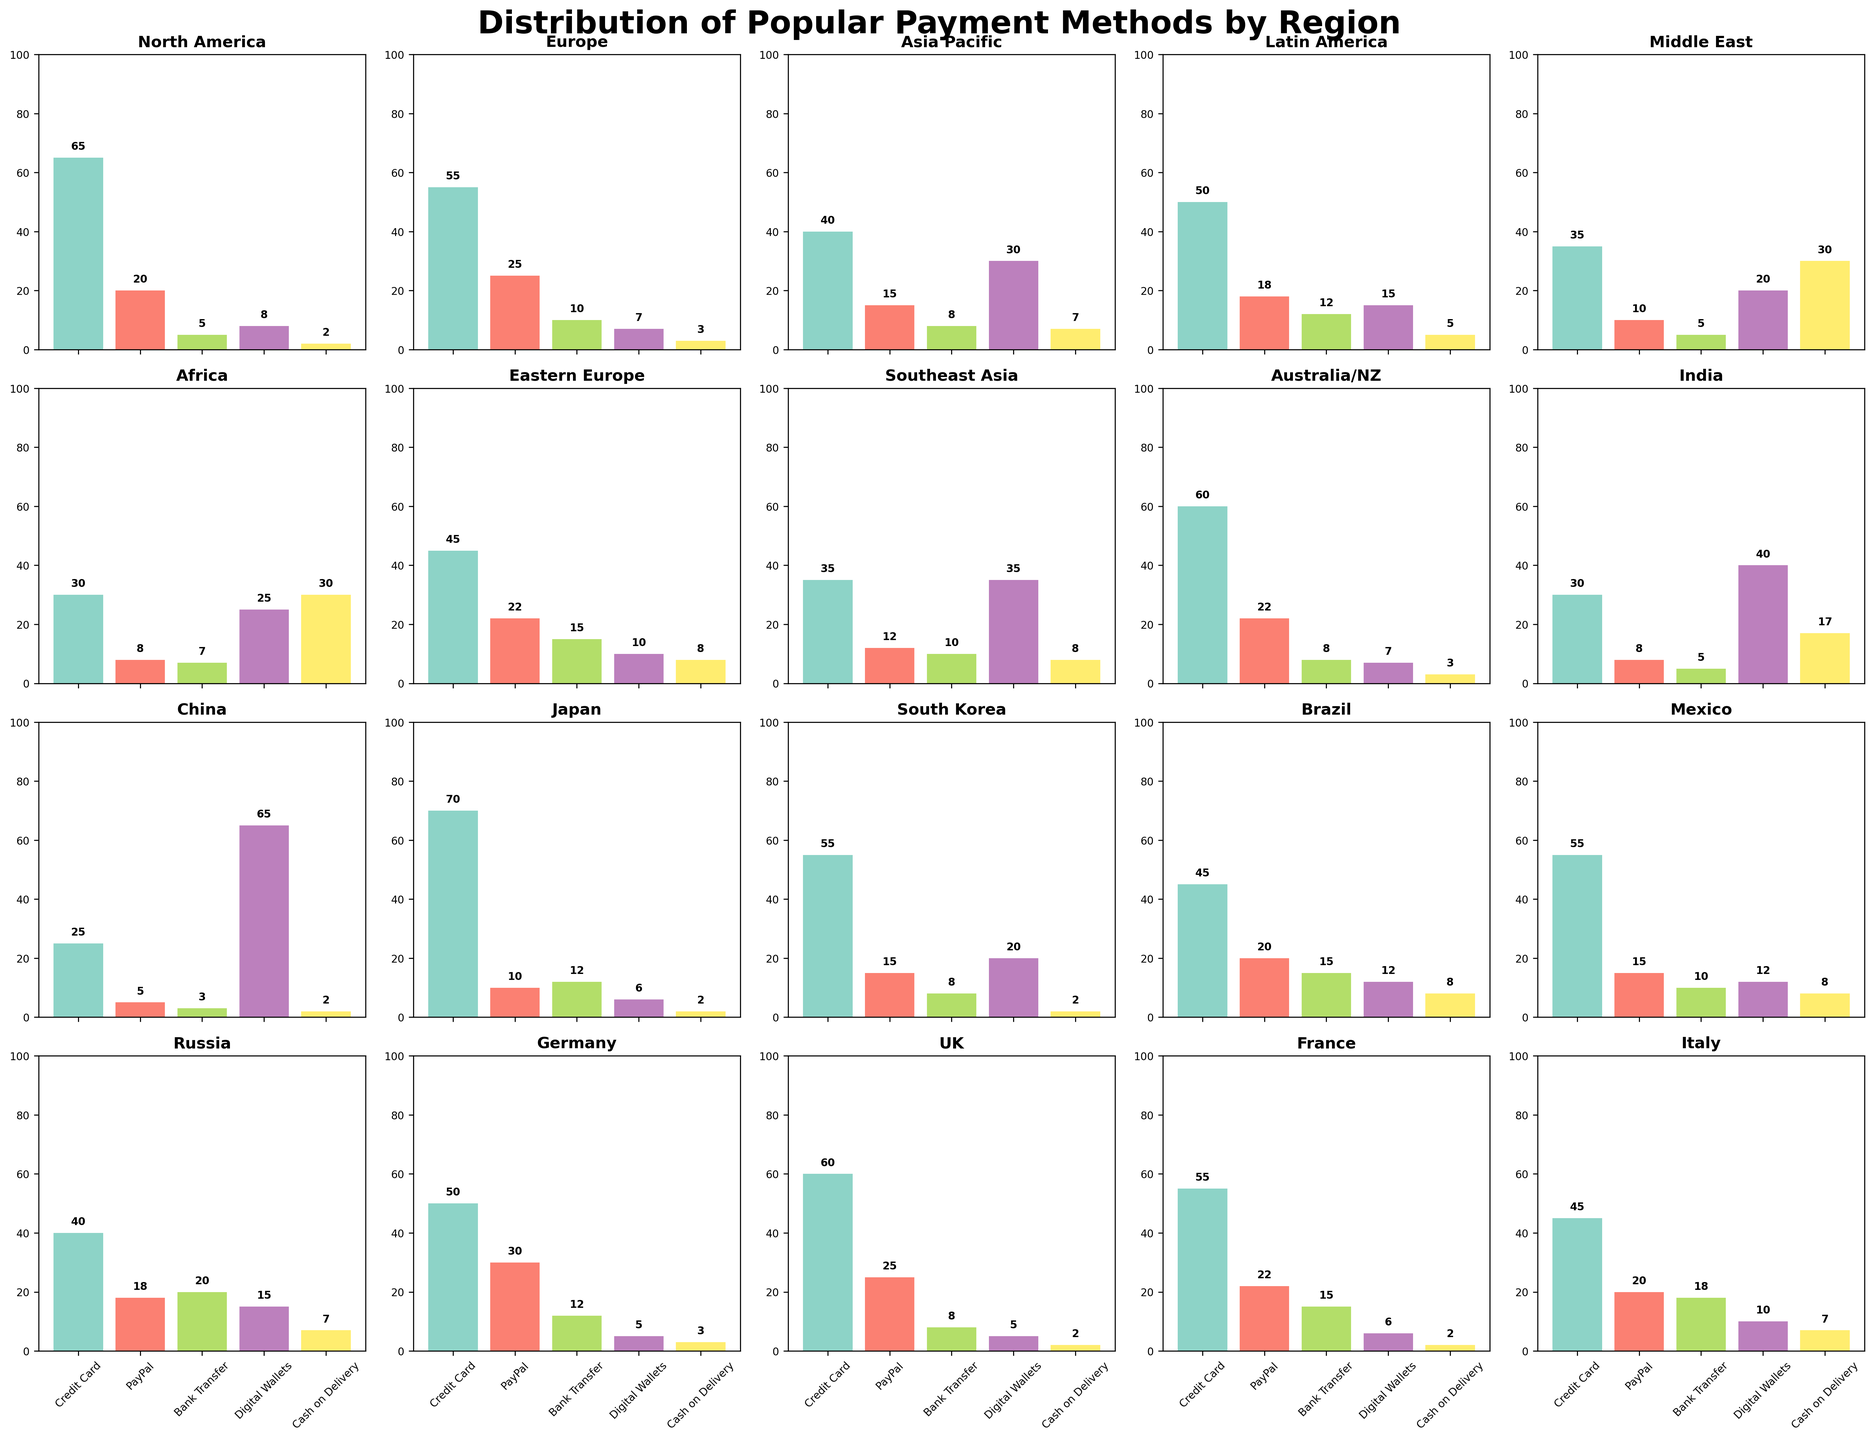What is the most popular payment method in North America? By examining the height of the bars in the North America subplot, the bar representing the Credit Card is the tallest, indicating it's the most popular payment method.
Answer: Credit Card Which region relies most on Digital Wallets, and how much is it used there? To determine this, look at the bars for Digital Wallets across all subplots. The tallest bar for Digital Wallets is in China, with a value of 65.
Answer: China, 65 Compare the usage of PayPal between Europe and North America. Which region has higher usage, and by how much? By comparing the height of the PayPal bars in Europe and North America subplots, Europe has a taller bar at 25 compared to North America's 20. The difference is 25 - 20 = 5.
Answer: Europe, 5 Which two regions have the same percentage for Bank Transfer, and what is that percentage? Checking the Bank Transfer bars in all subplots, Latin America and Japan have the same height at 12.
Answer: Latin America and Japan, 12 In which region is Cash on Delivery the most popular payment method, and what percentage does it have? By looking at the Cash on Delivery bars, the tallest one is in the Middle East at 30, making it the most popular method there.
Answer: Middle East, 30 How does the usage of Credit Card in Brazil compare to that in Mexico? By comparing the Credit Card bars in Brazil and Mexico subplots, both have the same height at 45.
Answer: Same, 45 What is the average usage of Digital Wallets in Asia Pacific and Southeast Asia? To find the average, sum the Digital Wallets percentages in Asia Pacific (30) and Southeast Asia (35) and divide by 2: (30 + 35) / 2 = 32.5.
Answer: 32.5 Which region has the smallest percentage of Bank Transfer usage, and what is that percentage? The smallest Bank Transfer bar can be found by visual inspection, which is in China at 3.
Answer: China, 3 Compare the usage of Digital Wallets and Cash on Delivery in Africa. What can you conclude? In the Africa subplot, the Digital Wallets bar is at 25, and the Cash on Delivery bar is at 30. Cash on Delivery is higher by 5.
Answer: Cash on Delivery is higher by 5 